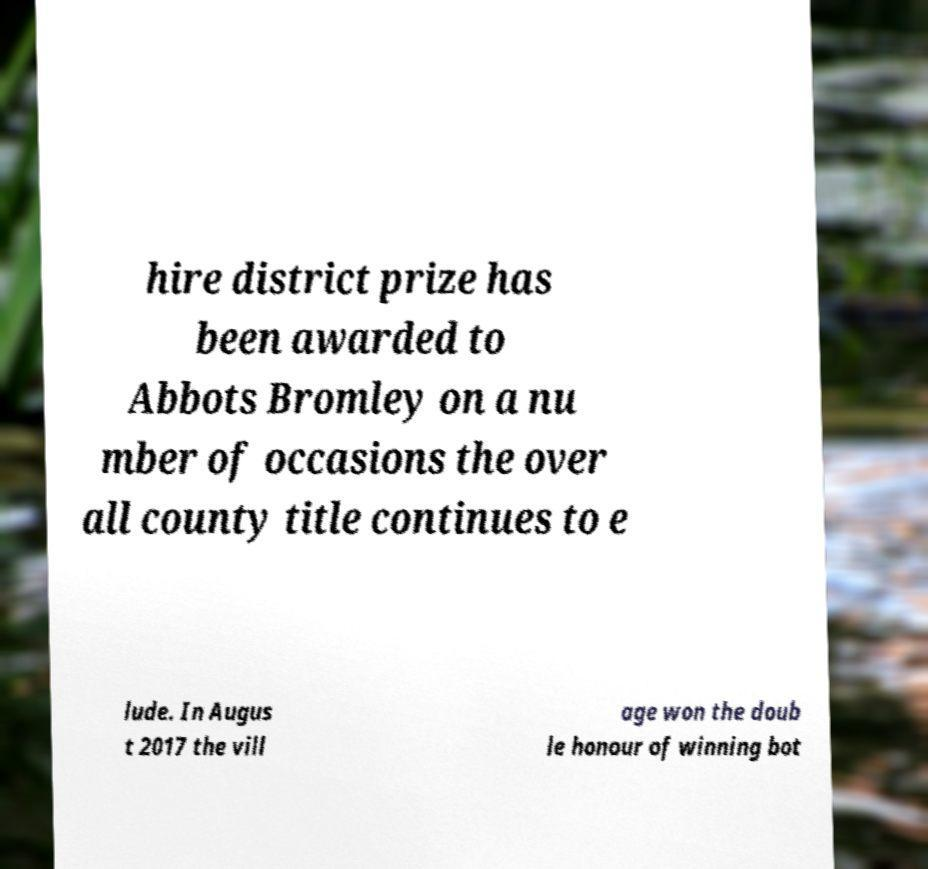I need the written content from this picture converted into text. Can you do that? hire district prize has been awarded to Abbots Bromley on a nu mber of occasions the over all county title continues to e lude. In Augus t 2017 the vill age won the doub le honour of winning bot 